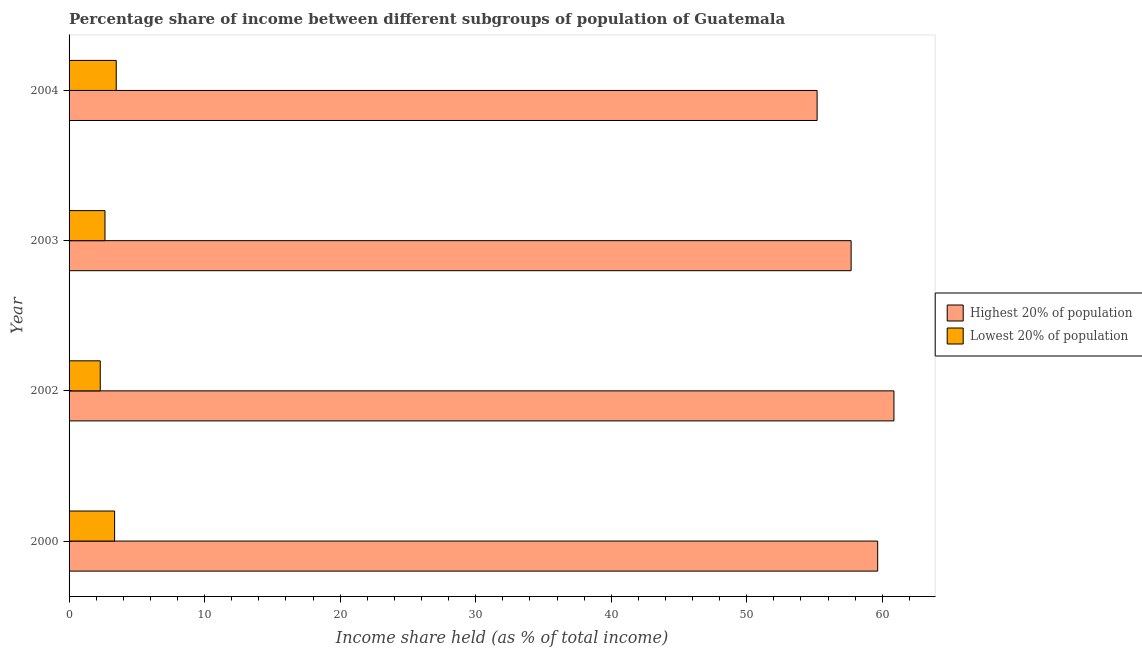How many different coloured bars are there?
Your answer should be compact. 2. Are the number of bars per tick equal to the number of legend labels?
Offer a terse response. Yes. How many bars are there on the 4th tick from the top?
Your answer should be compact. 2. What is the label of the 3rd group of bars from the top?
Keep it short and to the point. 2002. In how many cases, is the number of bars for a given year not equal to the number of legend labels?
Offer a very short reply. 0. What is the income share held by lowest 20% of the population in 2003?
Offer a terse response. 2.65. Across all years, what is the maximum income share held by highest 20% of the population?
Make the answer very short. 60.86. Across all years, what is the minimum income share held by lowest 20% of the population?
Keep it short and to the point. 2.3. In which year was the income share held by highest 20% of the population maximum?
Give a very brief answer. 2002. What is the total income share held by lowest 20% of the population in the graph?
Your answer should be very brief. 11.79. What is the difference between the income share held by lowest 20% of the population in 2003 and that in 2004?
Provide a succinct answer. -0.83. What is the difference between the income share held by lowest 20% of the population in 2002 and the income share held by highest 20% of the population in 2003?
Offer a very short reply. -55.4. What is the average income share held by lowest 20% of the population per year?
Provide a succinct answer. 2.95. In the year 2002, what is the difference between the income share held by lowest 20% of the population and income share held by highest 20% of the population?
Offer a very short reply. -58.56. What is the ratio of the income share held by highest 20% of the population in 2000 to that in 2002?
Provide a short and direct response. 0.98. What is the difference between the highest and the lowest income share held by highest 20% of the population?
Provide a succinct answer. 5.67. In how many years, is the income share held by lowest 20% of the population greater than the average income share held by lowest 20% of the population taken over all years?
Keep it short and to the point. 2. Is the sum of the income share held by highest 20% of the population in 2000 and 2002 greater than the maximum income share held by lowest 20% of the population across all years?
Give a very brief answer. Yes. What does the 1st bar from the top in 2004 represents?
Give a very brief answer. Lowest 20% of population. What does the 1st bar from the bottom in 2002 represents?
Provide a succinct answer. Highest 20% of population. How many years are there in the graph?
Your answer should be very brief. 4. What is the difference between two consecutive major ticks on the X-axis?
Offer a terse response. 10. Are the values on the major ticks of X-axis written in scientific E-notation?
Make the answer very short. No. Does the graph contain grids?
Your answer should be compact. No. How many legend labels are there?
Provide a short and direct response. 2. How are the legend labels stacked?
Your response must be concise. Vertical. What is the title of the graph?
Your response must be concise. Percentage share of income between different subgroups of population of Guatemala. Does "Ages 15-24" appear as one of the legend labels in the graph?
Ensure brevity in your answer.  No. What is the label or title of the X-axis?
Offer a very short reply. Income share held (as % of total income). What is the Income share held (as % of total income) of Highest 20% of population in 2000?
Ensure brevity in your answer.  59.66. What is the Income share held (as % of total income) of Lowest 20% of population in 2000?
Offer a very short reply. 3.36. What is the Income share held (as % of total income) of Highest 20% of population in 2002?
Offer a terse response. 60.86. What is the Income share held (as % of total income) of Highest 20% of population in 2003?
Make the answer very short. 57.7. What is the Income share held (as % of total income) in Lowest 20% of population in 2003?
Your answer should be very brief. 2.65. What is the Income share held (as % of total income) in Highest 20% of population in 2004?
Your answer should be compact. 55.19. What is the Income share held (as % of total income) of Lowest 20% of population in 2004?
Your response must be concise. 3.48. Across all years, what is the maximum Income share held (as % of total income) of Highest 20% of population?
Offer a very short reply. 60.86. Across all years, what is the maximum Income share held (as % of total income) of Lowest 20% of population?
Give a very brief answer. 3.48. Across all years, what is the minimum Income share held (as % of total income) in Highest 20% of population?
Make the answer very short. 55.19. Across all years, what is the minimum Income share held (as % of total income) of Lowest 20% of population?
Keep it short and to the point. 2.3. What is the total Income share held (as % of total income) in Highest 20% of population in the graph?
Provide a succinct answer. 233.41. What is the total Income share held (as % of total income) of Lowest 20% of population in the graph?
Provide a succinct answer. 11.79. What is the difference between the Income share held (as % of total income) of Highest 20% of population in 2000 and that in 2002?
Provide a succinct answer. -1.2. What is the difference between the Income share held (as % of total income) of Lowest 20% of population in 2000 and that in 2002?
Make the answer very short. 1.06. What is the difference between the Income share held (as % of total income) of Highest 20% of population in 2000 and that in 2003?
Offer a terse response. 1.96. What is the difference between the Income share held (as % of total income) of Lowest 20% of population in 2000 and that in 2003?
Keep it short and to the point. 0.71. What is the difference between the Income share held (as % of total income) in Highest 20% of population in 2000 and that in 2004?
Your answer should be very brief. 4.47. What is the difference between the Income share held (as % of total income) in Lowest 20% of population in 2000 and that in 2004?
Your answer should be very brief. -0.12. What is the difference between the Income share held (as % of total income) in Highest 20% of population in 2002 and that in 2003?
Provide a succinct answer. 3.16. What is the difference between the Income share held (as % of total income) in Lowest 20% of population in 2002 and that in 2003?
Offer a terse response. -0.35. What is the difference between the Income share held (as % of total income) in Highest 20% of population in 2002 and that in 2004?
Ensure brevity in your answer.  5.67. What is the difference between the Income share held (as % of total income) in Lowest 20% of population in 2002 and that in 2004?
Offer a terse response. -1.18. What is the difference between the Income share held (as % of total income) of Highest 20% of population in 2003 and that in 2004?
Ensure brevity in your answer.  2.51. What is the difference between the Income share held (as % of total income) in Lowest 20% of population in 2003 and that in 2004?
Your answer should be very brief. -0.83. What is the difference between the Income share held (as % of total income) of Highest 20% of population in 2000 and the Income share held (as % of total income) of Lowest 20% of population in 2002?
Provide a succinct answer. 57.36. What is the difference between the Income share held (as % of total income) of Highest 20% of population in 2000 and the Income share held (as % of total income) of Lowest 20% of population in 2003?
Offer a very short reply. 57.01. What is the difference between the Income share held (as % of total income) of Highest 20% of population in 2000 and the Income share held (as % of total income) of Lowest 20% of population in 2004?
Your answer should be very brief. 56.18. What is the difference between the Income share held (as % of total income) of Highest 20% of population in 2002 and the Income share held (as % of total income) of Lowest 20% of population in 2003?
Offer a terse response. 58.21. What is the difference between the Income share held (as % of total income) of Highest 20% of population in 2002 and the Income share held (as % of total income) of Lowest 20% of population in 2004?
Your answer should be compact. 57.38. What is the difference between the Income share held (as % of total income) of Highest 20% of population in 2003 and the Income share held (as % of total income) of Lowest 20% of population in 2004?
Your response must be concise. 54.22. What is the average Income share held (as % of total income) in Highest 20% of population per year?
Keep it short and to the point. 58.35. What is the average Income share held (as % of total income) in Lowest 20% of population per year?
Provide a succinct answer. 2.95. In the year 2000, what is the difference between the Income share held (as % of total income) of Highest 20% of population and Income share held (as % of total income) of Lowest 20% of population?
Your answer should be very brief. 56.3. In the year 2002, what is the difference between the Income share held (as % of total income) in Highest 20% of population and Income share held (as % of total income) in Lowest 20% of population?
Provide a short and direct response. 58.56. In the year 2003, what is the difference between the Income share held (as % of total income) of Highest 20% of population and Income share held (as % of total income) of Lowest 20% of population?
Provide a short and direct response. 55.05. In the year 2004, what is the difference between the Income share held (as % of total income) in Highest 20% of population and Income share held (as % of total income) in Lowest 20% of population?
Make the answer very short. 51.71. What is the ratio of the Income share held (as % of total income) of Highest 20% of population in 2000 to that in 2002?
Provide a succinct answer. 0.98. What is the ratio of the Income share held (as % of total income) of Lowest 20% of population in 2000 to that in 2002?
Offer a terse response. 1.46. What is the ratio of the Income share held (as % of total income) in Highest 20% of population in 2000 to that in 2003?
Ensure brevity in your answer.  1.03. What is the ratio of the Income share held (as % of total income) of Lowest 20% of population in 2000 to that in 2003?
Your response must be concise. 1.27. What is the ratio of the Income share held (as % of total income) in Highest 20% of population in 2000 to that in 2004?
Offer a terse response. 1.08. What is the ratio of the Income share held (as % of total income) in Lowest 20% of population in 2000 to that in 2004?
Make the answer very short. 0.97. What is the ratio of the Income share held (as % of total income) of Highest 20% of population in 2002 to that in 2003?
Keep it short and to the point. 1.05. What is the ratio of the Income share held (as % of total income) in Lowest 20% of population in 2002 to that in 2003?
Offer a very short reply. 0.87. What is the ratio of the Income share held (as % of total income) in Highest 20% of population in 2002 to that in 2004?
Your response must be concise. 1.1. What is the ratio of the Income share held (as % of total income) of Lowest 20% of population in 2002 to that in 2004?
Provide a short and direct response. 0.66. What is the ratio of the Income share held (as % of total income) of Highest 20% of population in 2003 to that in 2004?
Your response must be concise. 1.05. What is the ratio of the Income share held (as % of total income) of Lowest 20% of population in 2003 to that in 2004?
Your answer should be very brief. 0.76. What is the difference between the highest and the second highest Income share held (as % of total income) in Lowest 20% of population?
Provide a short and direct response. 0.12. What is the difference between the highest and the lowest Income share held (as % of total income) of Highest 20% of population?
Your answer should be compact. 5.67. What is the difference between the highest and the lowest Income share held (as % of total income) of Lowest 20% of population?
Your answer should be very brief. 1.18. 